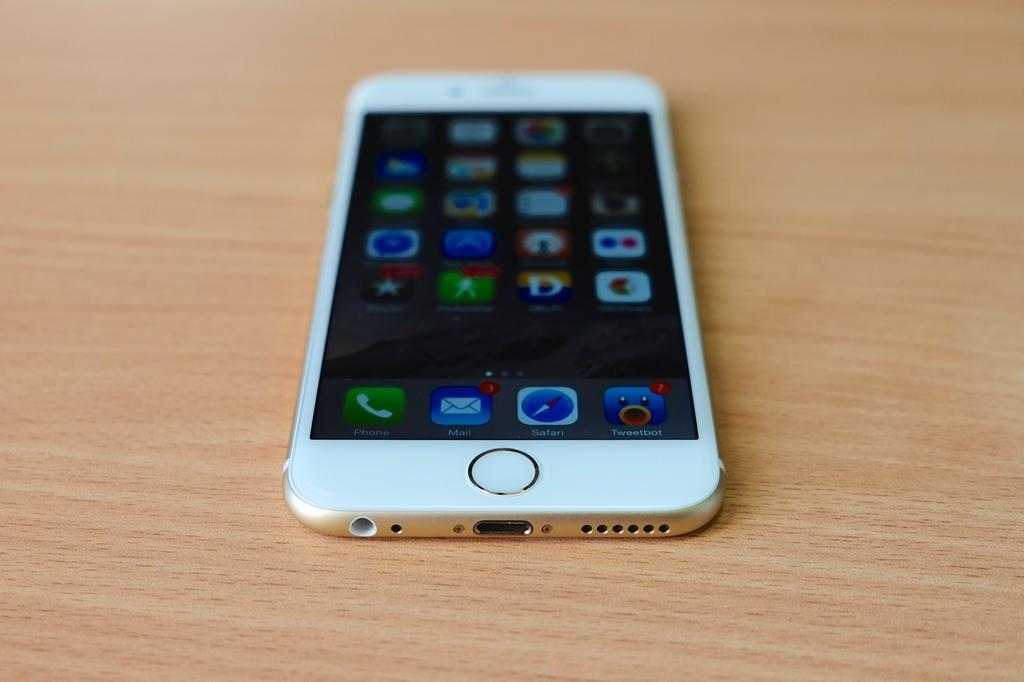What object is located on the table in the image? There is a mobile on the table in the image. What type of cherry is being used in the battle scene depicted in the mobile? There is no battle scene or cherry present in the image; it features a mobile on the table. 